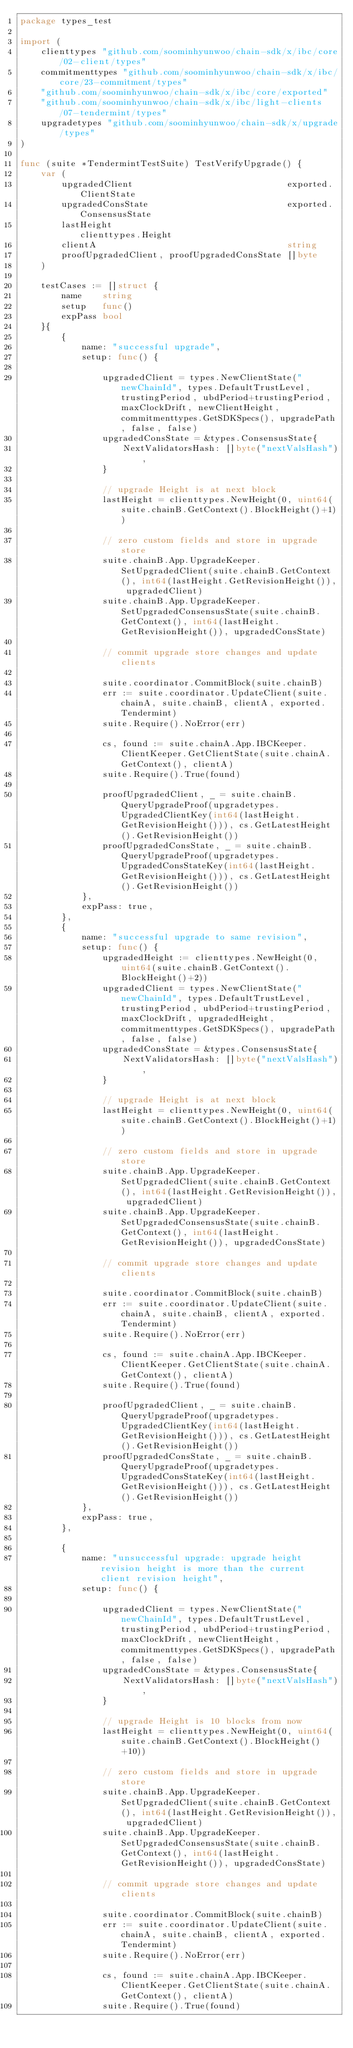<code> <loc_0><loc_0><loc_500><loc_500><_Go_>package types_test

import (
	clienttypes "github.com/soominhyunwoo/chain-sdk/x/ibc/core/02-client/types"
	commitmenttypes "github.com/soominhyunwoo/chain-sdk/x/ibc/core/23-commitment/types"
	"github.com/soominhyunwoo/chain-sdk/x/ibc/core/exported"
	"github.com/soominhyunwoo/chain-sdk/x/ibc/light-clients/07-tendermint/types"
	upgradetypes "github.com/soominhyunwoo/chain-sdk/x/upgrade/types"
)

func (suite *TendermintTestSuite) TestVerifyUpgrade() {
	var (
		upgradedClient                              exported.ClientState
		upgradedConsState                           exported.ConsensusState
		lastHeight                                  clienttypes.Height
		clientA                                     string
		proofUpgradedClient, proofUpgradedConsState []byte
	)

	testCases := []struct {
		name    string
		setup   func()
		expPass bool
	}{
		{
			name: "successful upgrade",
			setup: func() {

				upgradedClient = types.NewClientState("newChainId", types.DefaultTrustLevel, trustingPeriod, ubdPeriod+trustingPeriod, maxClockDrift, newClientHeight, commitmenttypes.GetSDKSpecs(), upgradePath, false, false)
				upgradedConsState = &types.ConsensusState{
					NextValidatorsHash: []byte("nextValsHash"),
				}

				// upgrade Height is at next block
				lastHeight = clienttypes.NewHeight(0, uint64(suite.chainB.GetContext().BlockHeight()+1))

				// zero custom fields and store in upgrade store
				suite.chainB.App.UpgradeKeeper.SetUpgradedClient(suite.chainB.GetContext(), int64(lastHeight.GetRevisionHeight()), upgradedClient)
				suite.chainB.App.UpgradeKeeper.SetUpgradedConsensusState(suite.chainB.GetContext(), int64(lastHeight.GetRevisionHeight()), upgradedConsState)

				// commit upgrade store changes and update clients

				suite.coordinator.CommitBlock(suite.chainB)
				err := suite.coordinator.UpdateClient(suite.chainA, suite.chainB, clientA, exported.Tendermint)
				suite.Require().NoError(err)

				cs, found := suite.chainA.App.IBCKeeper.ClientKeeper.GetClientState(suite.chainA.GetContext(), clientA)
				suite.Require().True(found)

				proofUpgradedClient, _ = suite.chainB.QueryUpgradeProof(upgradetypes.UpgradedClientKey(int64(lastHeight.GetRevisionHeight())), cs.GetLatestHeight().GetRevisionHeight())
				proofUpgradedConsState, _ = suite.chainB.QueryUpgradeProof(upgradetypes.UpgradedConsStateKey(int64(lastHeight.GetRevisionHeight())), cs.GetLatestHeight().GetRevisionHeight())
			},
			expPass: true,
		},
		{
			name: "successful upgrade to same revision",
			setup: func() {
				upgradedHeight := clienttypes.NewHeight(0, uint64(suite.chainB.GetContext().BlockHeight()+2))
				upgradedClient = types.NewClientState("newChainId", types.DefaultTrustLevel, trustingPeriod, ubdPeriod+trustingPeriod, maxClockDrift, upgradedHeight, commitmenttypes.GetSDKSpecs(), upgradePath, false, false)
				upgradedConsState = &types.ConsensusState{
					NextValidatorsHash: []byte("nextValsHash"),
				}

				// upgrade Height is at next block
				lastHeight = clienttypes.NewHeight(0, uint64(suite.chainB.GetContext().BlockHeight()+1))

				// zero custom fields and store in upgrade store
				suite.chainB.App.UpgradeKeeper.SetUpgradedClient(suite.chainB.GetContext(), int64(lastHeight.GetRevisionHeight()), upgradedClient)
				suite.chainB.App.UpgradeKeeper.SetUpgradedConsensusState(suite.chainB.GetContext(), int64(lastHeight.GetRevisionHeight()), upgradedConsState)

				// commit upgrade store changes and update clients

				suite.coordinator.CommitBlock(suite.chainB)
				err := suite.coordinator.UpdateClient(suite.chainA, suite.chainB, clientA, exported.Tendermint)
				suite.Require().NoError(err)

				cs, found := suite.chainA.App.IBCKeeper.ClientKeeper.GetClientState(suite.chainA.GetContext(), clientA)
				suite.Require().True(found)

				proofUpgradedClient, _ = suite.chainB.QueryUpgradeProof(upgradetypes.UpgradedClientKey(int64(lastHeight.GetRevisionHeight())), cs.GetLatestHeight().GetRevisionHeight())
				proofUpgradedConsState, _ = suite.chainB.QueryUpgradeProof(upgradetypes.UpgradedConsStateKey(int64(lastHeight.GetRevisionHeight())), cs.GetLatestHeight().GetRevisionHeight())
			},
			expPass: true,
		},

		{
			name: "unsuccessful upgrade: upgrade height revision height is more than the current client revision height",
			setup: func() {

				upgradedClient = types.NewClientState("newChainId", types.DefaultTrustLevel, trustingPeriod, ubdPeriod+trustingPeriod, maxClockDrift, newClientHeight, commitmenttypes.GetSDKSpecs(), upgradePath, false, false)
				upgradedConsState = &types.ConsensusState{
					NextValidatorsHash: []byte("nextValsHash"),
				}

				// upgrade Height is 10 blocks from now
				lastHeight = clienttypes.NewHeight(0, uint64(suite.chainB.GetContext().BlockHeight()+10))

				// zero custom fields and store in upgrade store
				suite.chainB.App.UpgradeKeeper.SetUpgradedClient(suite.chainB.GetContext(), int64(lastHeight.GetRevisionHeight()), upgradedClient)
				suite.chainB.App.UpgradeKeeper.SetUpgradedConsensusState(suite.chainB.GetContext(), int64(lastHeight.GetRevisionHeight()), upgradedConsState)

				// commit upgrade store changes and update clients

				suite.coordinator.CommitBlock(suite.chainB)
				err := suite.coordinator.UpdateClient(suite.chainA, suite.chainB, clientA, exported.Tendermint)
				suite.Require().NoError(err)

				cs, found := suite.chainA.App.IBCKeeper.ClientKeeper.GetClientState(suite.chainA.GetContext(), clientA)
				suite.Require().True(found)
</code> 